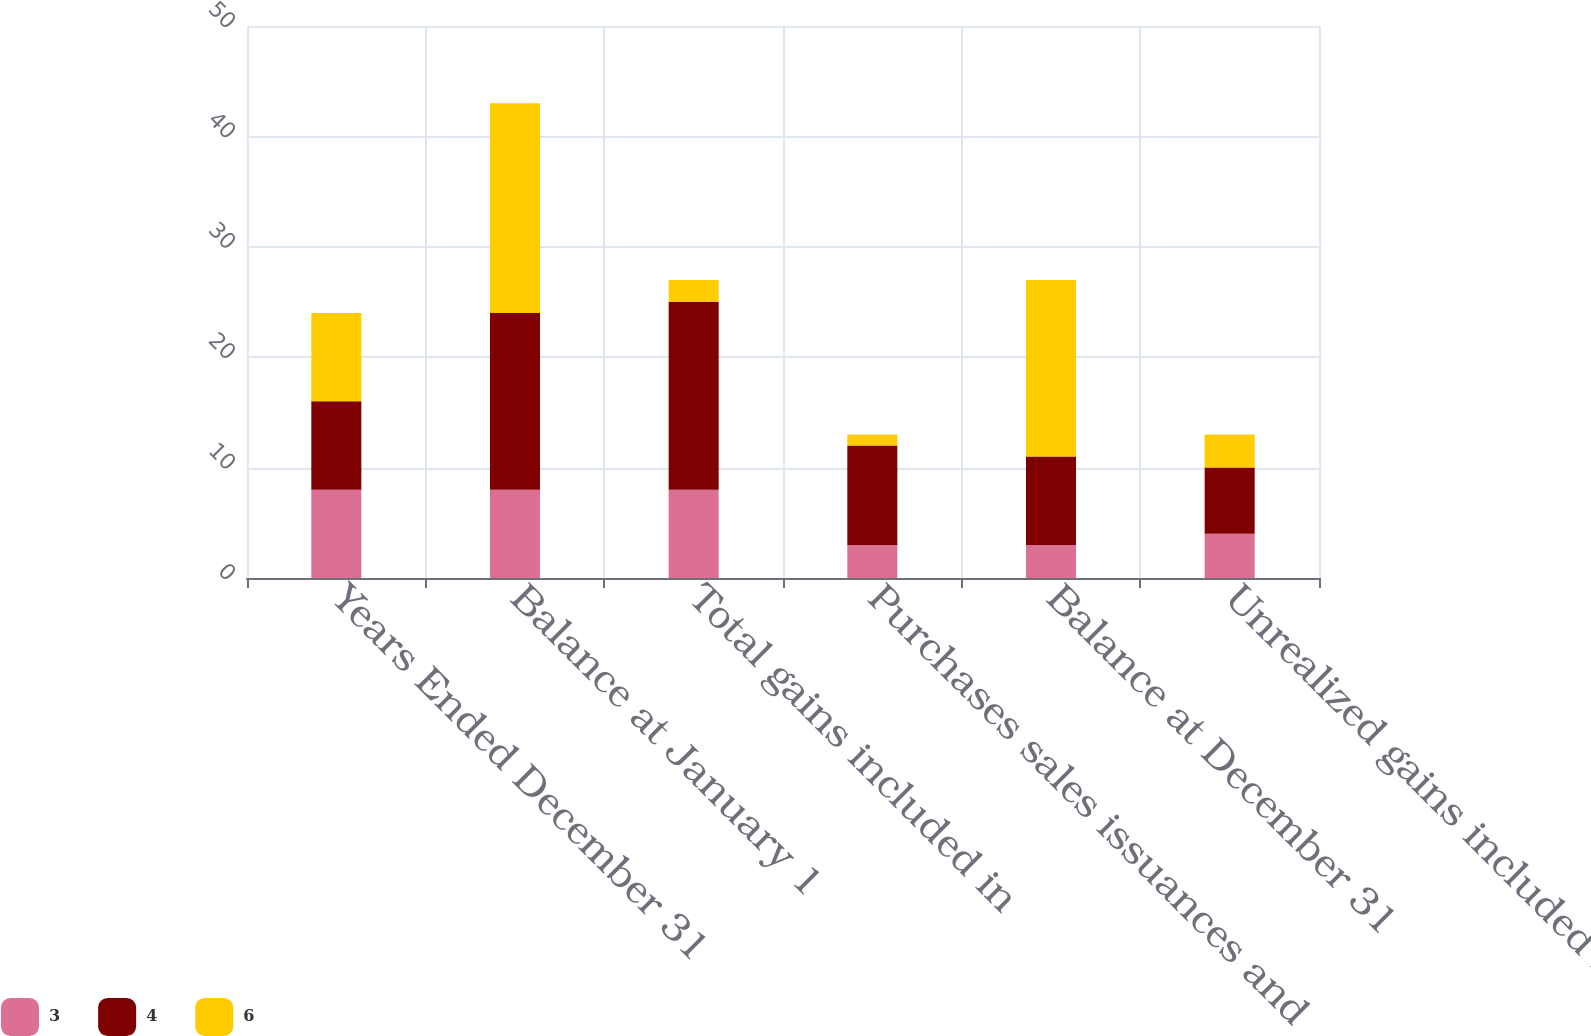<chart> <loc_0><loc_0><loc_500><loc_500><stacked_bar_chart><ecel><fcel>Years Ended December 31<fcel>Balance at January 1<fcel>Total gains included in<fcel>Purchases sales issuances and<fcel>Balance at December 31<fcel>Unrealized gains included in<nl><fcel>3<fcel>8<fcel>8<fcel>8<fcel>3<fcel>3<fcel>4<nl><fcel>4<fcel>8<fcel>16<fcel>17<fcel>9<fcel>8<fcel>6<nl><fcel>6<fcel>8<fcel>19<fcel>2<fcel>1<fcel>16<fcel>3<nl></chart> 